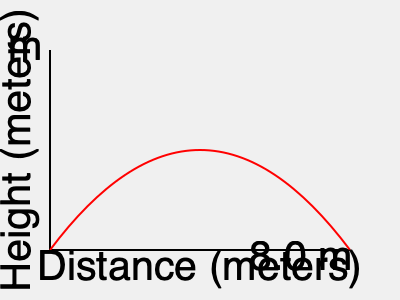Based on the trajectory shown in the graph, estimate the distance covered by the long jumper. Assume that the maximum height reached is 2.5 meters, and the total horizontal distance is 8.0 meters. What is the approximate length of the curved path taken by the jumper's center of mass? To estimate the length of the curved path:

1. Recognize that the path is roughly parabolic.
2. Approximate the curve as an arc of a circle.
3. Calculate the chord length (straight-line distance):
   $c = \sqrt{8.0^2 + 2.5^2} = \sqrt{64 + 6.25} = \sqrt{70.25} \approx 8.38$ m
4. Find the sagitta (maximum height of the arc from the chord):
   $s = 2.5$ m (given maximum height)
5. Use the formula for arc length: $L = 2r \arcsin(\frac{c}{2r})$
   where $r$ is the radius of the circle
6. Calculate the radius: $r = \frac{c^2}{8s} + \frac{s}{2} = \frac{8.38^2}{20} + 1.25 \approx 4.76$ m
7. Substitute into the arc length formula:
   $L = 2(4.76) \arcsin(\frac{8.38}{2(4.76)}) \approx 8.79$ m

Therefore, the approximate length of the curved path is 8.79 meters.
Answer: 8.79 meters 